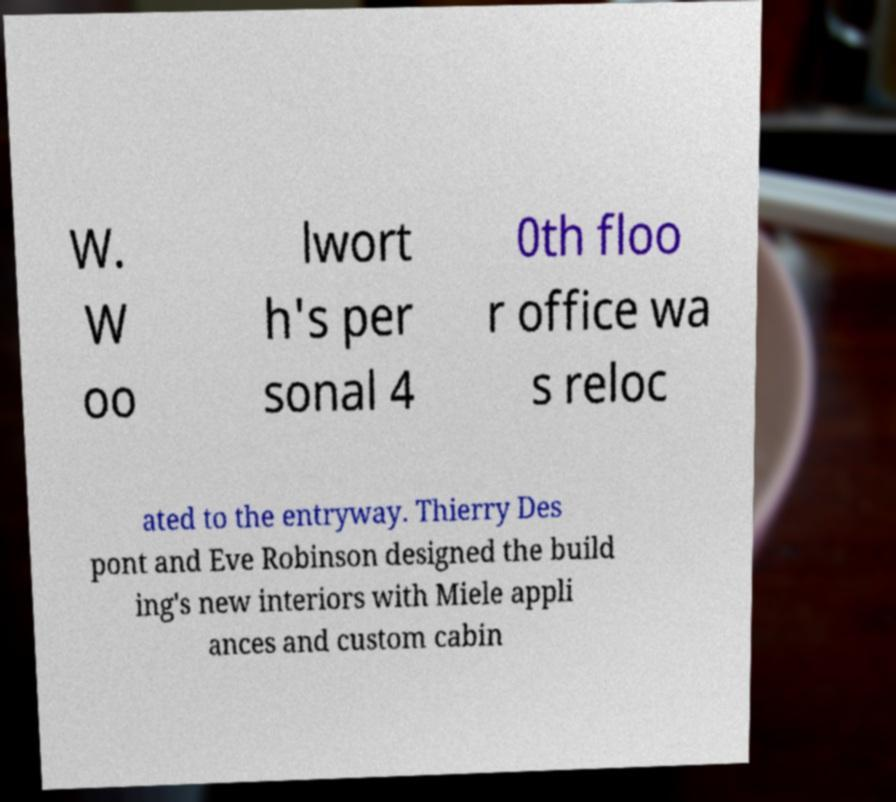Please read and relay the text visible in this image. What does it say? W. W oo lwort h's per sonal 4 0th floo r office wa s reloc ated to the entryway. Thierry Des pont and Eve Robinson designed the build ing's new interiors with Miele appli ances and custom cabin 